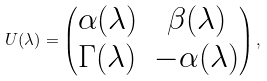Convert formula to latex. <formula><loc_0><loc_0><loc_500><loc_500>U ( \lambda ) = \left ( \begin{matrix} \alpha ( \lambda ) & \beta ( \lambda ) \\ \Gamma ( \lambda ) & - \alpha ( \lambda ) \end{matrix} \right ) ,</formula> 